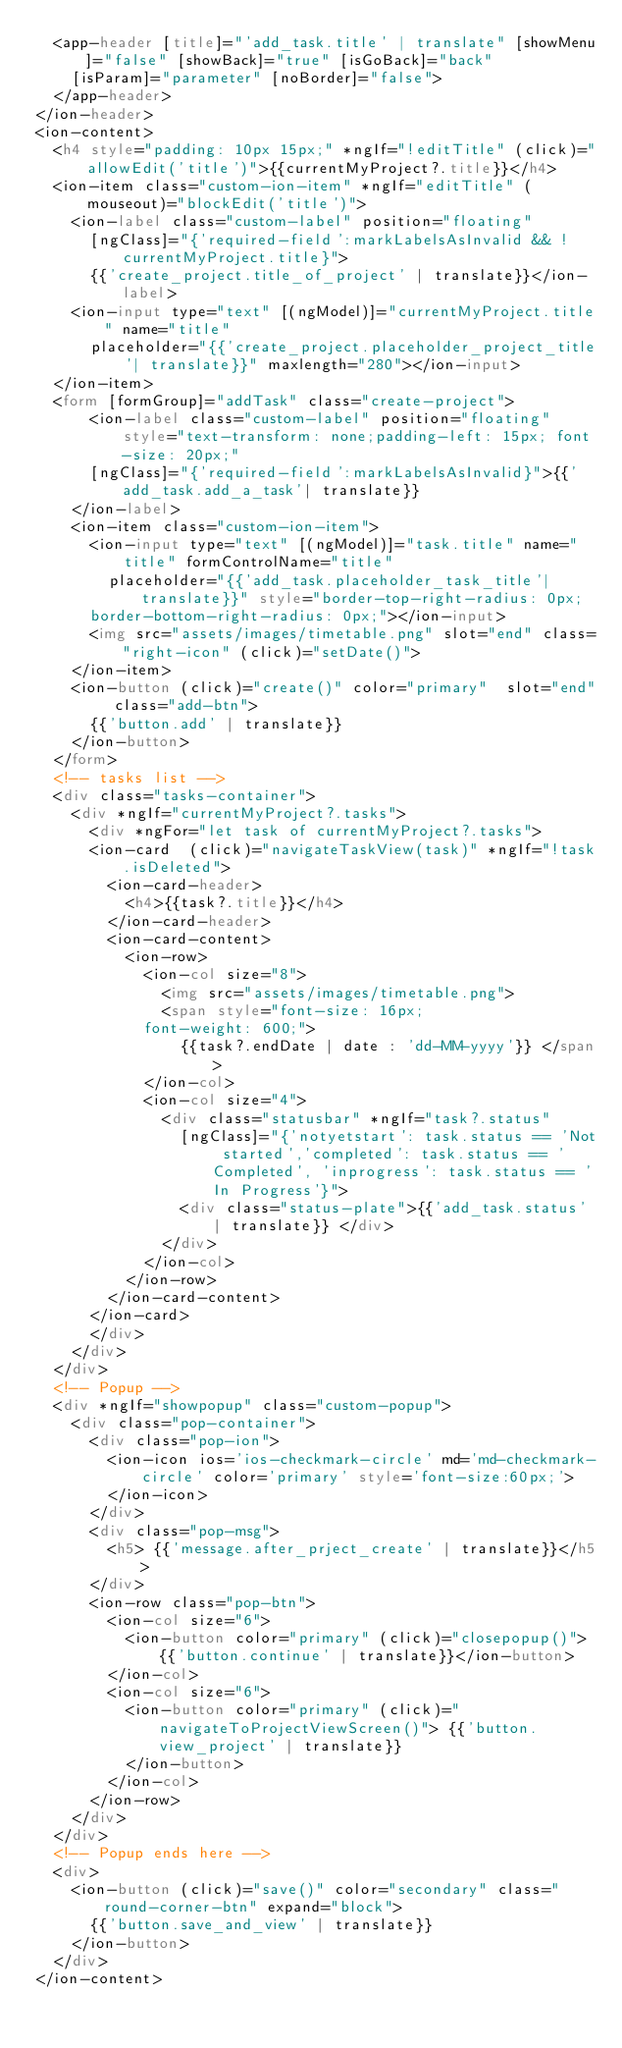<code> <loc_0><loc_0><loc_500><loc_500><_HTML_>  <app-header [title]="'add_task.title' | translate" [showMenu]="false" [showBack]="true" [isGoBack]="back"
    [isParam]="parameter" [noBorder]="false">
  </app-header>
</ion-header>
<ion-content>
  <h4 style="padding: 10px 15px;" *ngIf="!editTitle" (click)="allowEdit('title')">{{currentMyProject?.title}}</h4>
  <ion-item class="custom-ion-item" *ngIf="editTitle" (mouseout)="blockEdit('title')">
    <ion-label class="custom-label" position="floating"
      [ngClass]="{'required-field':markLabelsAsInvalid && !currentMyProject.title}">
      {{'create_project.title_of_project' | translate}}</ion-label>
    <ion-input type="text" [(ngModel)]="currentMyProject.title" name="title"
      placeholder="{{'create_project.placeholder_project_title'| translate}}" maxlength="280"></ion-input>
  </ion-item>
  <form [formGroup]="addTask" class="create-project">
      <ion-label class="custom-label" position="floating" style="text-transform: none;padding-left: 15px; font-size: 20px;"
      [ngClass]="{'required-field':markLabelsAsInvalid}">{{'add_task.add_a_task'| translate}}
    </ion-label>
    <ion-item class="custom-ion-item">
      <ion-input type="text" [(ngModel)]="task.title" name="title" formControlName="title"
        placeholder="{{'add_task.placeholder_task_title'| translate}}" style="border-top-right-radius: 0px;
      border-bottom-right-radius: 0px;"></ion-input>
      <img src="assets/images/timetable.png" slot="end" class="right-icon" (click)="setDate()">
    </ion-item>
    <ion-button (click)="create()" color="primary"  slot="end" class="add-btn">
      {{'button.add' | translate}}
    </ion-button>
  </form>
  <!-- tasks list -->
  <div class="tasks-container">
    <div *ngIf="currentMyProject?.tasks">
      <div *ngFor="let task of currentMyProject?.tasks">
      <ion-card  (click)="navigateTaskView(task)" *ngIf="!task.isDeleted">
        <ion-card-header>
          <h4>{{task?.title}}</h4>
        </ion-card-header>
        <ion-card-content>
          <ion-row>
            <ion-col size="8">
              <img src="assets/images/timetable.png">
              <span style="font-size: 16px;
            font-weight: 600;">
                {{task?.endDate | date : 'dd-MM-yyyy'}} </span>
            </ion-col>
            <ion-col size="4">
              <div class="statusbar" *ngIf="task?.status"
                [ngClass]="{'notyetstart': task.status == 'Not started','completed': task.status == 'Completed', 'inprogress': task.status == 'In Progress'}">
                <div class="status-plate">{{'add_task.status' | translate}} </div>
              </div>
            </ion-col>
          </ion-row>
        </ion-card-content>
      </ion-card>
      </div>
    </div>
  </div>
  <!-- Popup -->
  <div *ngIf="showpopup" class="custom-popup">
    <div class="pop-container">
      <div class="pop-ion">
        <ion-icon ios='ios-checkmark-circle' md='md-checkmark-circle' color='primary' style='font-size:60px;'>
        </ion-icon>
      </div>
      <div class="pop-msg">
        <h5> {{'message.after_prject_create' | translate}}</h5>
      </div>
      <ion-row class="pop-btn">
        <ion-col size="6">
          <ion-button color="primary" (click)="closepopup()"> {{'button.continue' | translate}}</ion-button>
        </ion-col>
        <ion-col size="6">
          <ion-button color="primary" (click)="navigateToProjectViewScreen()"> {{'button.view_project' | translate}}
          </ion-button>
        </ion-col>
      </ion-row>
    </div>
  </div>
  <!-- Popup ends here -->
  <div>
    <ion-button (click)="save()" color="secondary" class="round-corner-btn" expand="block">
      {{'button.save_and_view' | translate}}
    </ion-button>
  </div>
</ion-content></code> 